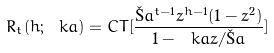<formula> <loc_0><loc_0><loc_500><loc_500>R _ { t } ( h ; \ k a ) = C T [ \frac { \L a ^ { t - 1 } z ^ { h - 1 } ( 1 - z ^ { 2 } ) } { 1 - \ k a z / \L a } ]</formula> 